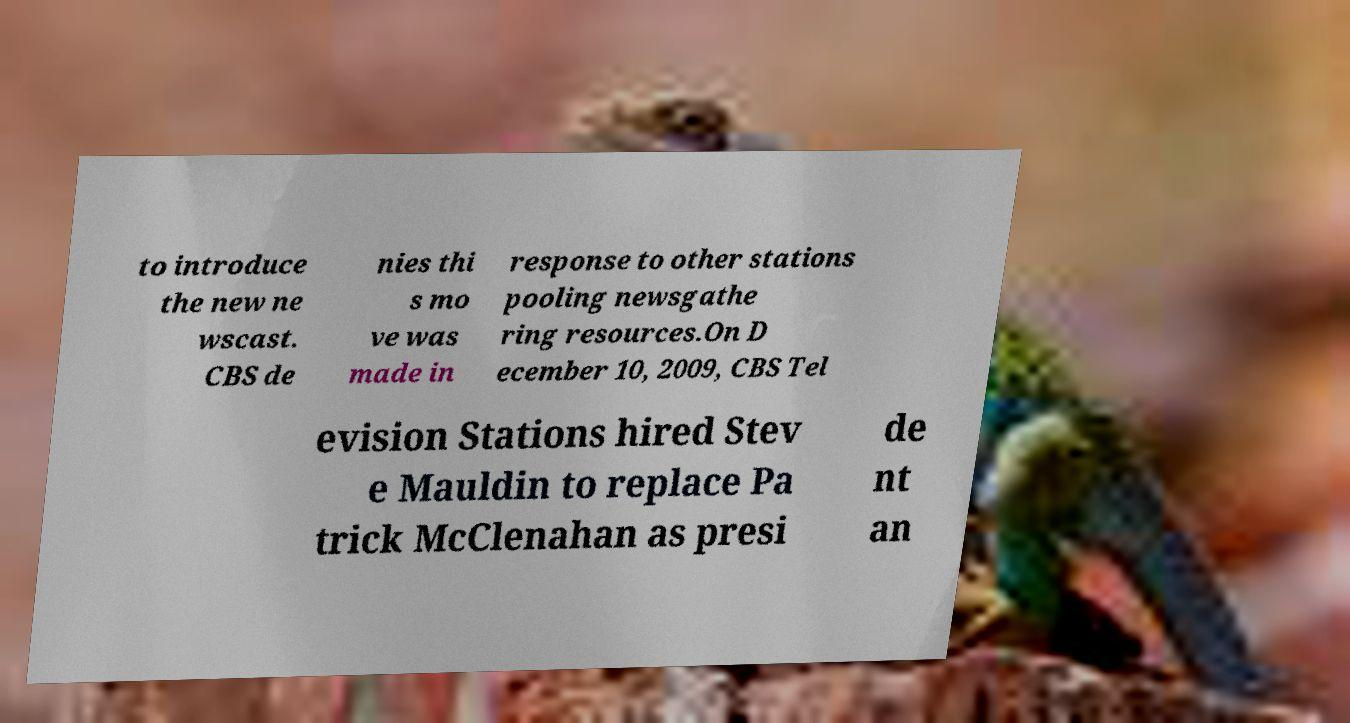Can you accurately transcribe the text from the provided image for me? to introduce the new ne wscast. CBS de nies thi s mo ve was made in response to other stations pooling newsgathe ring resources.On D ecember 10, 2009, CBS Tel evision Stations hired Stev e Mauldin to replace Pa trick McClenahan as presi de nt an 